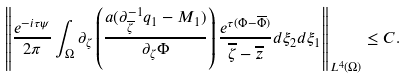Convert formula to latex. <formula><loc_0><loc_0><loc_500><loc_500>\left \| \frac { e ^ { - i \tau \psi } } { 2 \pi } \int _ { \Omega } \partial _ { \zeta } \left ( \frac { a ( \partial ^ { - 1 } _ { \overline { \zeta } } q _ { 1 } - M _ { 1 } ) } { \partial _ { \zeta } \Phi } \right ) \frac { e ^ { \tau ( \Phi - \overline { \Phi } ) } } { \overline { \zeta } - \overline { z } } d \xi _ { 2 } d \xi _ { 1 } \right \| _ { L ^ { 4 } ( \Omega ) } \leq C .</formula> 